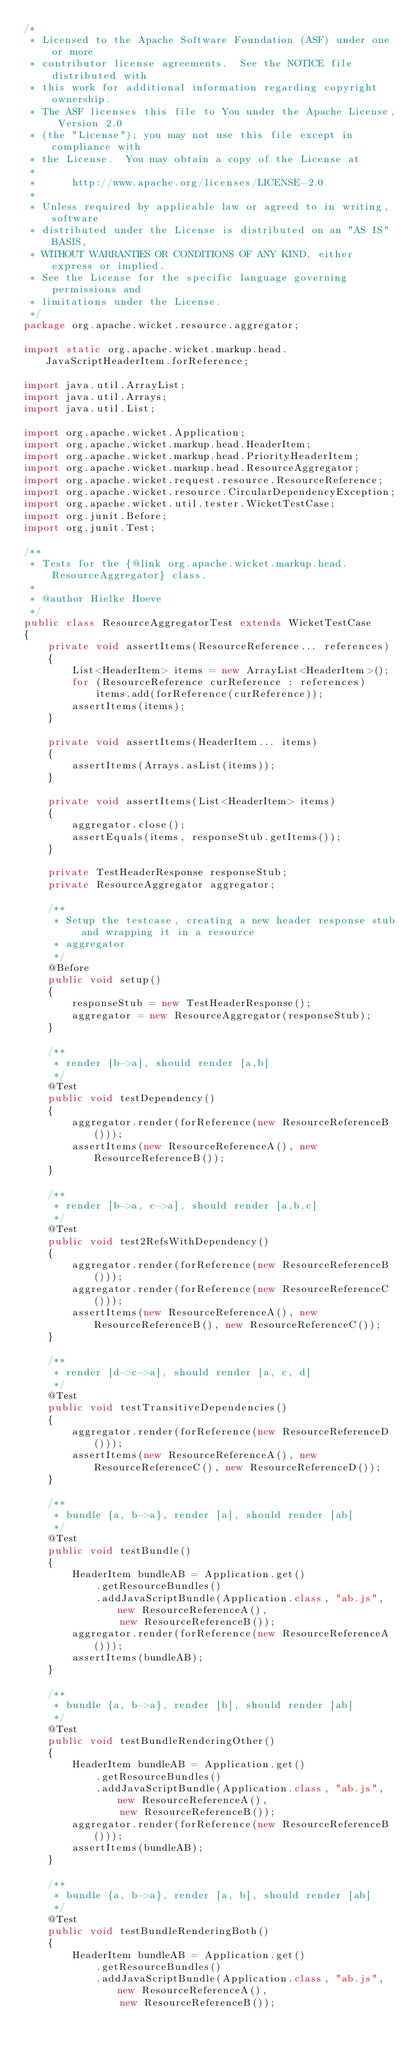Convert code to text. <code><loc_0><loc_0><loc_500><loc_500><_Java_>/*
 * Licensed to the Apache Software Foundation (ASF) under one or more
 * contributor license agreements.  See the NOTICE file distributed with
 * this work for additional information regarding copyright ownership.
 * The ASF licenses this file to You under the Apache License, Version 2.0
 * (the "License"); you may not use this file except in compliance with
 * the License.  You may obtain a copy of the License at
 *
 *      http://www.apache.org/licenses/LICENSE-2.0
 *
 * Unless required by applicable law or agreed to in writing, software
 * distributed under the License is distributed on an "AS IS" BASIS,
 * WITHOUT WARRANTIES OR CONDITIONS OF ANY KIND, either express or implied.
 * See the License for the specific language governing permissions and
 * limitations under the License.
 */
package org.apache.wicket.resource.aggregator;

import static org.apache.wicket.markup.head.JavaScriptHeaderItem.forReference;

import java.util.ArrayList;
import java.util.Arrays;
import java.util.List;

import org.apache.wicket.Application;
import org.apache.wicket.markup.head.HeaderItem;
import org.apache.wicket.markup.head.PriorityHeaderItem;
import org.apache.wicket.markup.head.ResourceAggregator;
import org.apache.wicket.request.resource.ResourceReference;
import org.apache.wicket.resource.CircularDependencyException;
import org.apache.wicket.util.tester.WicketTestCase;
import org.junit.Before;
import org.junit.Test;

/**
 * Tests for the {@link org.apache.wicket.markup.head.ResourceAggregator} class.
 * 
 * @author Hielke Hoeve
 */
public class ResourceAggregatorTest extends WicketTestCase
{
	private void assertItems(ResourceReference... references)
	{
		List<HeaderItem> items = new ArrayList<HeaderItem>();
		for (ResourceReference curReference : references)
			items.add(forReference(curReference));
		assertItems(items);
	}

	private void assertItems(HeaderItem... items)
	{
		assertItems(Arrays.asList(items));
	}

	private void assertItems(List<HeaderItem> items)
	{
		aggregator.close();
		assertEquals(items, responseStub.getItems());
	}

	private TestHeaderResponse responseStub;
	private ResourceAggregator aggregator;

	/**
	 * Setup the testcase, creating a new header response stub and wrapping it in a resource
	 * aggregator
	 */
	@Before
	public void setup()
	{
		responseStub = new TestHeaderResponse();
		aggregator = new ResourceAggregator(responseStub);
	}

	/**
	 * render [b->a], should render [a,b]
	 */
	@Test
	public void testDependency()
	{
		aggregator.render(forReference(new ResourceReferenceB()));
		assertItems(new ResourceReferenceA(), new ResourceReferenceB());
	}

	/**
	 * render [b->a, c->a], should render [a,b,c]
	 */
	@Test
	public void test2RefsWithDependency()
	{
		aggregator.render(forReference(new ResourceReferenceB()));
		aggregator.render(forReference(new ResourceReferenceC()));
		assertItems(new ResourceReferenceA(), new ResourceReferenceB(), new ResourceReferenceC());
	}

	/**
	 * render [d->c->a], should render [a, c, d]
	 */
	@Test
	public void testTransitiveDependencies()
	{
		aggregator.render(forReference(new ResourceReferenceD()));
		assertItems(new ResourceReferenceA(), new ResourceReferenceC(), new ResourceReferenceD());
	}

	/**
	 * bundle {a, b->a}, render [a], should render [ab]
	 */
	@Test
	public void testBundle()
	{
		HeaderItem bundleAB = Application.get()
			.getResourceBundles()
			.addJavaScriptBundle(Application.class, "ab.js", new ResourceReferenceA(),
				new ResourceReferenceB());
		aggregator.render(forReference(new ResourceReferenceA()));
		assertItems(bundleAB);
	}

	/**
	 * bundle {a, b->a}, render [b], should render [ab]
	 */
	@Test
	public void testBundleRenderingOther()
	{
		HeaderItem bundleAB = Application.get()
			.getResourceBundles()
			.addJavaScriptBundle(Application.class, "ab.js", new ResourceReferenceA(),
				new ResourceReferenceB());
		aggregator.render(forReference(new ResourceReferenceB()));
		assertItems(bundleAB);
	}

	/**
	 * bundle {a, b->a}, render [a, b], should render [ab]
	 */
	@Test
	public void testBundleRenderingBoth()
	{
		HeaderItem bundleAB = Application.get()
			.getResourceBundles()
			.addJavaScriptBundle(Application.class, "ab.js", new ResourceReferenceA(),
				new ResourceReferenceB());</code> 